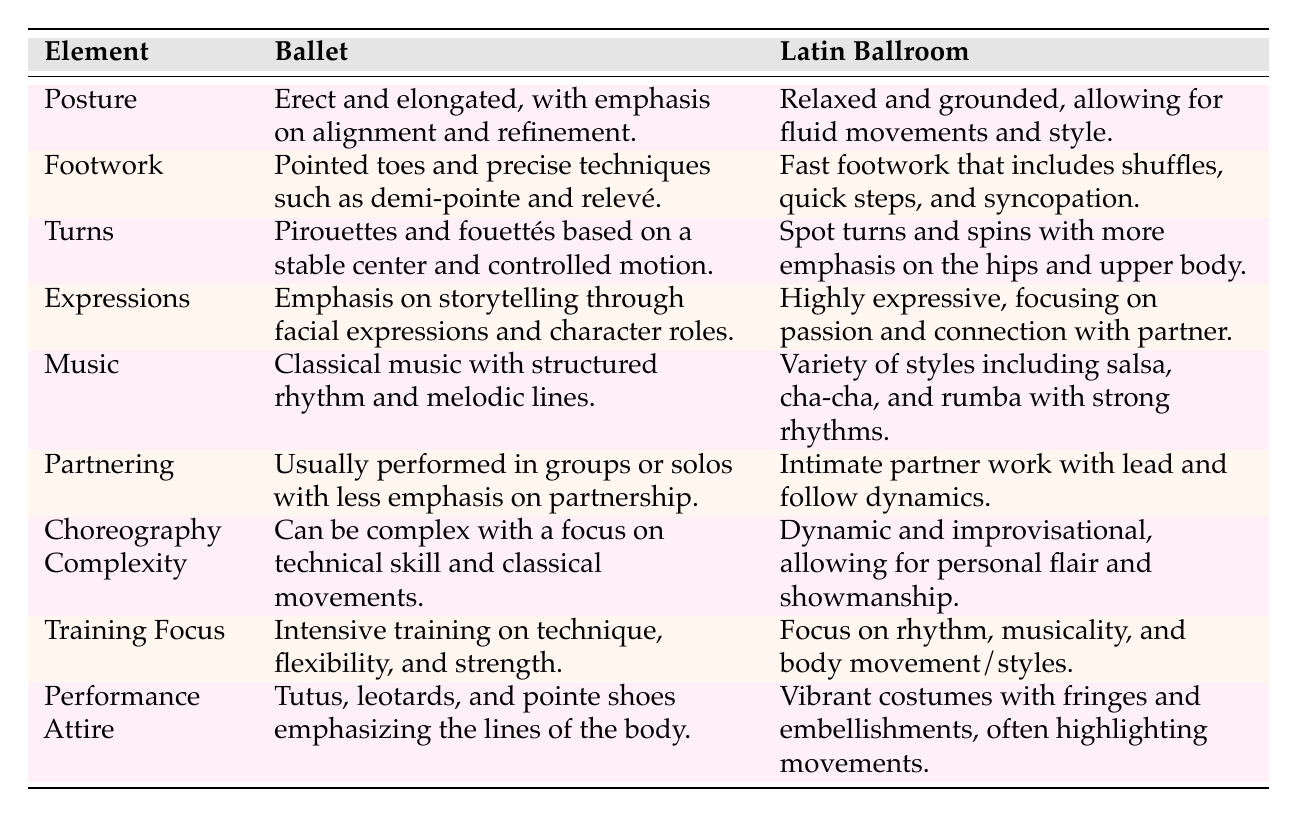What is the focus of ballet training? The table states that ballet training focuses on technique, flexibility, and strength. This specific information can be found under "Training Focus" in the ballet column.
Answer: Technique, flexibility, and strength How does the footwork in Latin ballroom differ from ballet? The table indicates that Latin ballroom features fast footwork, shuffles, quick steps, and syncopation, while ballet involves pointed toes and precise techniques like demi-pointe and relevé.
Answer: Fast footwork with shuffles and quick steps Is partner work emphasized in ballet? According to the table, ballet usually performs in groups or solos with less emphasis on partnership, while Latin ballroom specifically highlights intimate partner work. Thus, the answer to this question is no.
Answer: No What type of music is associated with Latin ballroom dancing? The table lists various styles of music associated with Latin ballroom, including salsa, cha-cha, and rumba, characterized by strong rhythms. This indicates a diversity in music types.
Answer: Salsa, cha-cha, and rumba Which dance style emphasizes storytelling through facial expressions? The table specifies that ballet places emphasis on storytelling through facial expressions and character roles, while Latin ballroom focuses on passion and connection with the partner.
Answer: Ballet What are the major differences in performance attire between ballet and Latin ballroom? From the table, ballet uses tutus, leotards, and pointe shoes to emphasize body lines, while Latin ballroom features vibrant costumes with fringes and embellishments to highlight movements. Both styles show very different approaches to attire.
Answer: Tutus for ballet, vibrant costumes for Latin ballroom How does the complexity of choreography in ballet compare to that in Latin ballroom? The table states that ballet can be complex with a focus on technical skill, while Latin ballroom is dynamic and improvisational, allowing for personal flair. This indicates ballet's complexity is more technical compared to the versatility in Latin ballroom.
Answer: Ballet is more technically complex Which dance style has a greater emphasis on upper body movement during turns? The table shows that Latin ballroom emphasizes more on the hips and upper body during turns, whereas ballet focuses on a stable center and controlled motion. Thus, the greater emphasis is found in Latin ballroom.
Answer: Latin ballroom How does the training focus differ between ballet and Latin ballroom? The table highlights that ballet training is intensive concerning technique, flexibility, and strength, while Latin ballroom focuses on rhythm, musicality, and body movement/styles. This indicates both styles have distinct training priorities.
Answer: Different training focuses: ballet on technique, Latin on rhythm What is the primary characteristic of posture in ballet? The table indicates that the posture in ballet is erect and elongated, with a focus on alignment and refinement. This specific information falls under the category of "Posture" in the ballet section.
Answer: Erect and elongated posture 